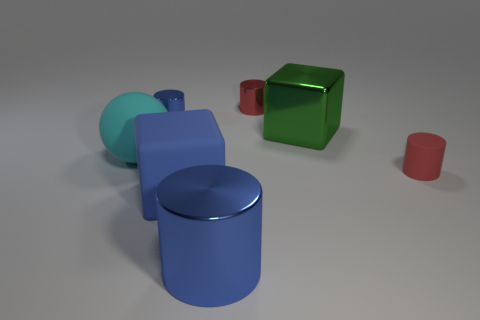Add 1 large blue rubber things. How many objects exist? 8 Subtract all blocks. How many objects are left? 5 Subtract 1 cyan balls. How many objects are left? 6 Subtract all big spheres. Subtract all red objects. How many objects are left? 4 Add 6 rubber spheres. How many rubber spheres are left? 7 Add 6 tiny red metallic things. How many tiny red metallic things exist? 7 